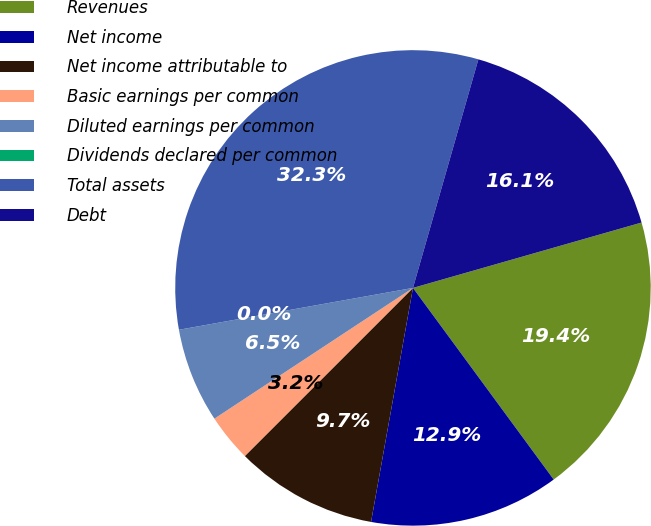Convert chart. <chart><loc_0><loc_0><loc_500><loc_500><pie_chart><fcel>Revenues<fcel>Net income<fcel>Net income attributable to<fcel>Basic earnings per common<fcel>Diluted earnings per common<fcel>Dividends declared per common<fcel>Total assets<fcel>Debt<nl><fcel>19.35%<fcel>12.9%<fcel>9.68%<fcel>3.23%<fcel>6.45%<fcel>0.0%<fcel>32.25%<fcel>16.13%<nl></chart> 